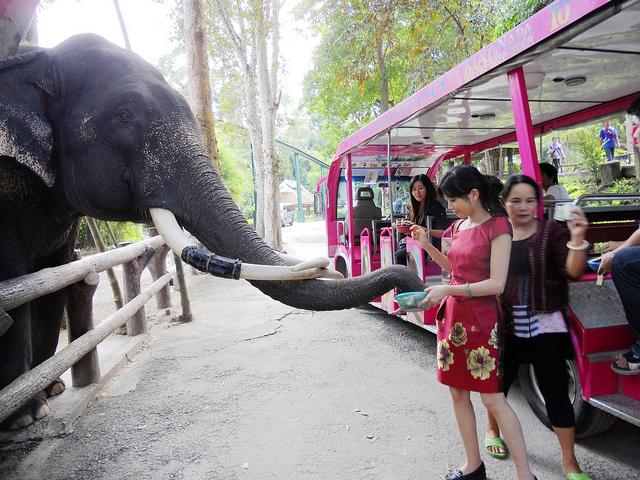What does the elephant seek?

Choices:
A) friendship
B) food
C) mate
D) baby elephants food 